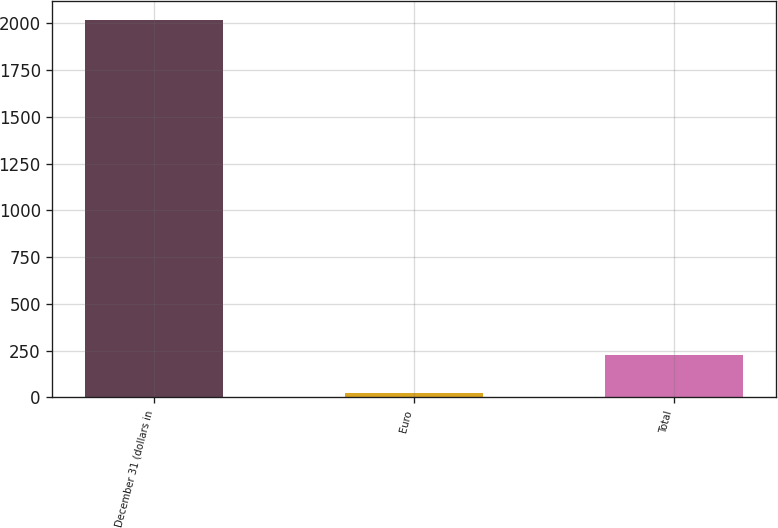<chart> <loc_0><loc_0><loc_500><loc_500><bar_chart><fcel>December 31 (dollars in<fcel>Euro<fcel>Total<nl><fcel>2016<fcel>25.4<fcel>224.46<nl></chart> 